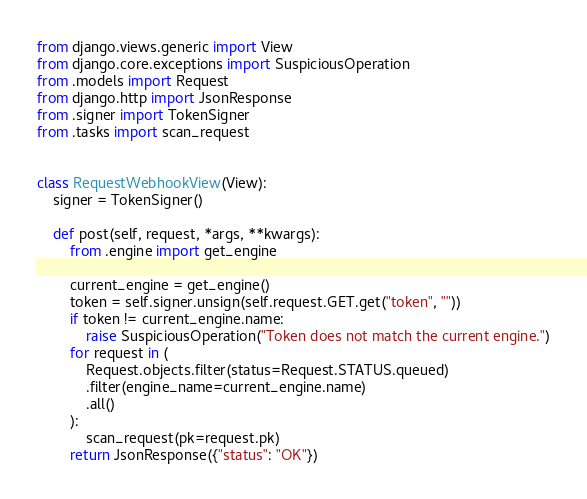<code> <loc_0><loc_0><loc_500><loc_500><_Python_>from django.views.generic import View
from django.core.exceptions import SuspiciousOperation
from .models import Request
from django.http import JsonResponse
from .signer import TokenSigner
from .tasks import scan_request


class RequestWebhookView(View):
    signer = TokenSigner()

    def post(self, request, *args, **kwargs):
        from .engine import get_engine

        current_engine = get_engine()
        token = self.signer.unsign(self.request.GET.get("token", ""))
        if token != current_engine.name:
            raise SuspiciousOperation("Token does not match the current engine.")
        for request in (
            Request.objects.filter(status=Request.STATUS.queued)
            .filter(engine_name=current_engine.name)
            .all()
        ):
            scan_request(pk=request.pk)
        return JsonResponse({"status": "OK"})
</code> 